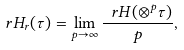Convert formula to latex. <formula><loc_0><loc_0><loc_500><loc_500>\ r H _ { r } ( \tau ) = \lim _ { p \to \infty } \frac { \ r H ( \otimes ^ { p } \tau ) } { p } ,</formula> 